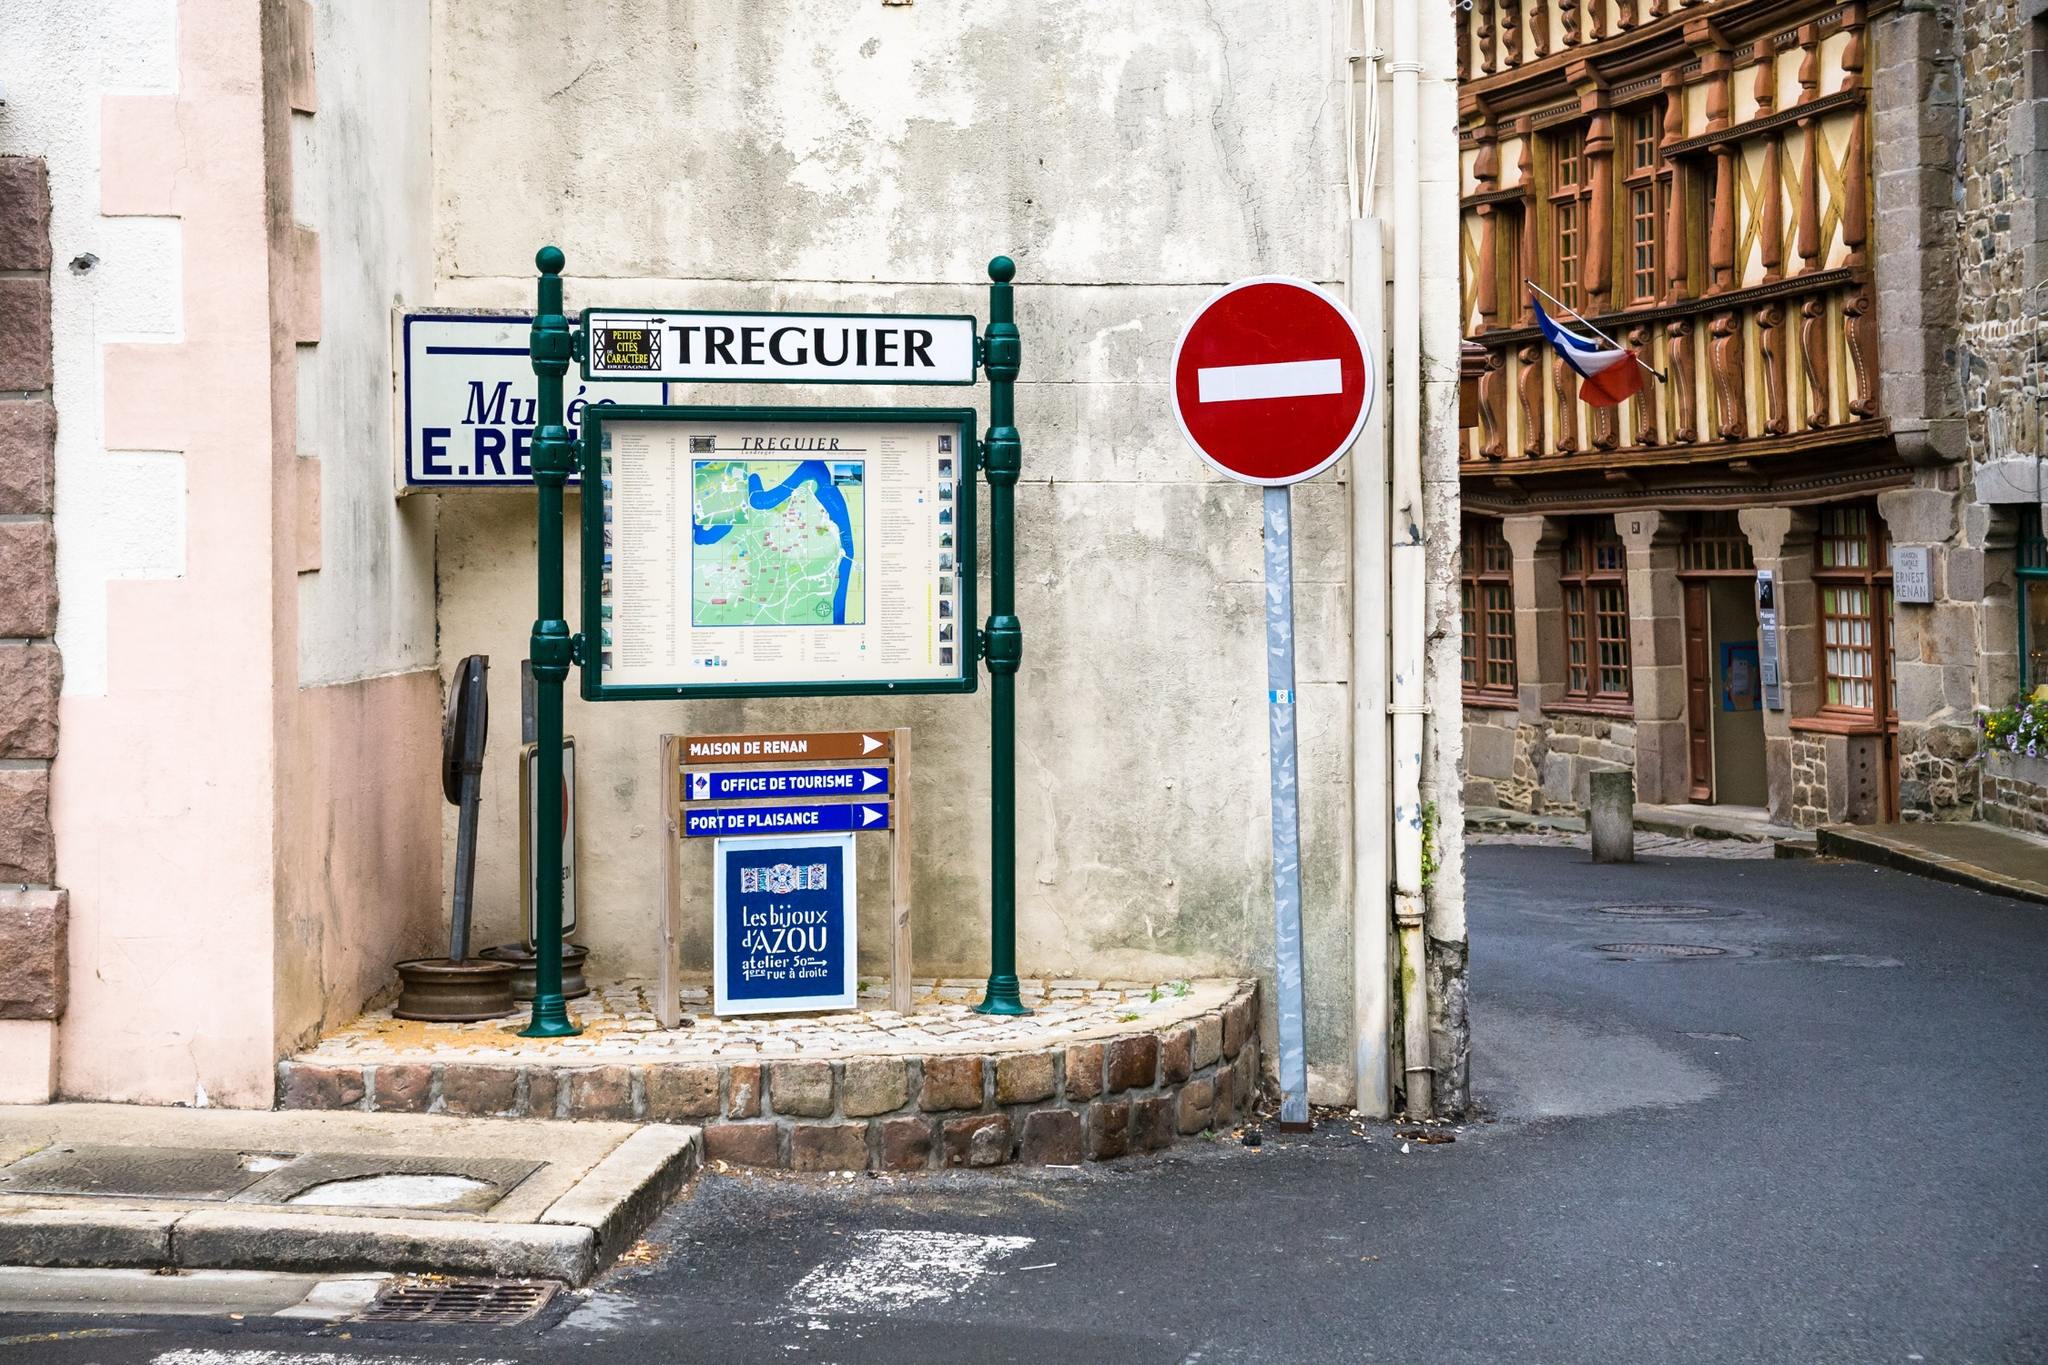Can you explain what kind of information might be on the map shown on the information board? The map on the information board is likely a detailed layout of Tréguier, pointing out key landmarks, historical sites, and tourist attractions. It might include walking routes, locations of public services, and possibly boat docking points given Tréguier's close proximity to the coast. 